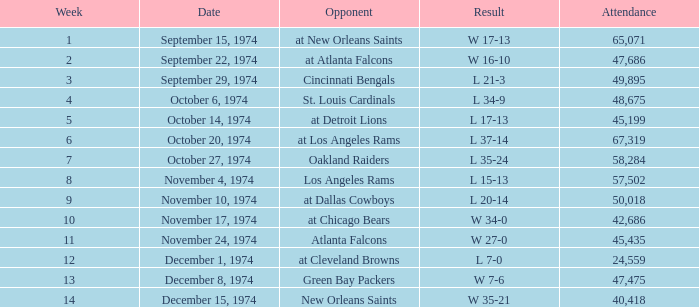Which week was the game played on December 8, 1974? 13.0. 